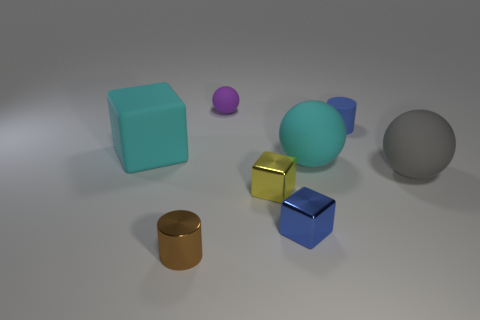Is there a big ball that has the same color as the matte block?
Your answer should be very brief. Yes. Does the gray ball have the same size as the brown cylinder?
Keep it short and to the point. No. The cyan thing right of the cylinder in front of the large gray matte ball is what shape?
Provide a succinct answer. Sphere. There is a blue rubber object; is its size the same as the block that is behind the gray matte thing?
Give a very brief answer. No. What is the material of the tiny cylinder to the left of the purple ball?
Keep it short and to the point. Metal. How many small objects are left of the tiny blue shiny thing and behind the tiny blue metallic object?
Your answer should be compact. 2. There is a brown cylinder that is the same size as the blue metal cube; what is its material?
Your response must be concise. Metal. There is a metallic thing that is right of the yellow shiny block; is its size the same as the cyan matte thing in front of the large cyan cube?
Provide a succinct answer. No. Are there any tiny matte balls to the right of the small matte cylinder?
Your response must be concise. No. There is a tiny metal thing that is behind the block on the right side of the small yellow thing; what is its color?
Provide a succinct answer. Yellow. 